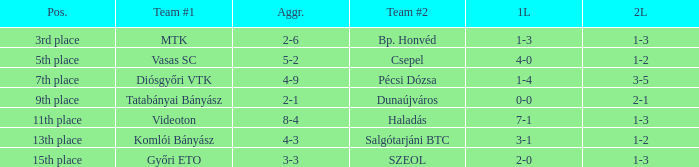What is the 1st leg with a 4-3 agg.? 3-1. Write the full table. {'header': ['Pos.', 'Team #1', 'Aggr.', 'Team #2', '1L', '2L'], 'rows': [['3rd place', 'MTK', '2-6', 'Bp. Honvéd', '1-3', '1-3'], ['5th place', 'Vasas SC', '5-2', 'Csepel', '4-0', '1-2'], ['7th place', 'Diósgyőri VTK', '4-9', 'Pécsi Dózsa', '1-4', '3-5'], ['9th place', 'Tatabányai Bányász', '2-1', 'Dunaújváros', '0-0', '2-1'], ['11th place', 'Videoton', '8-4', 'Haladás', '7-1', '1-3'], ['13th place', 'Komlói Bányász', '4-3', 'Salgótarjáni BTC', '3-1', '1-2'], ['15th place', 'Győri ETO', '3-3', 'SZEOL', '2-0', '1-3']]} 